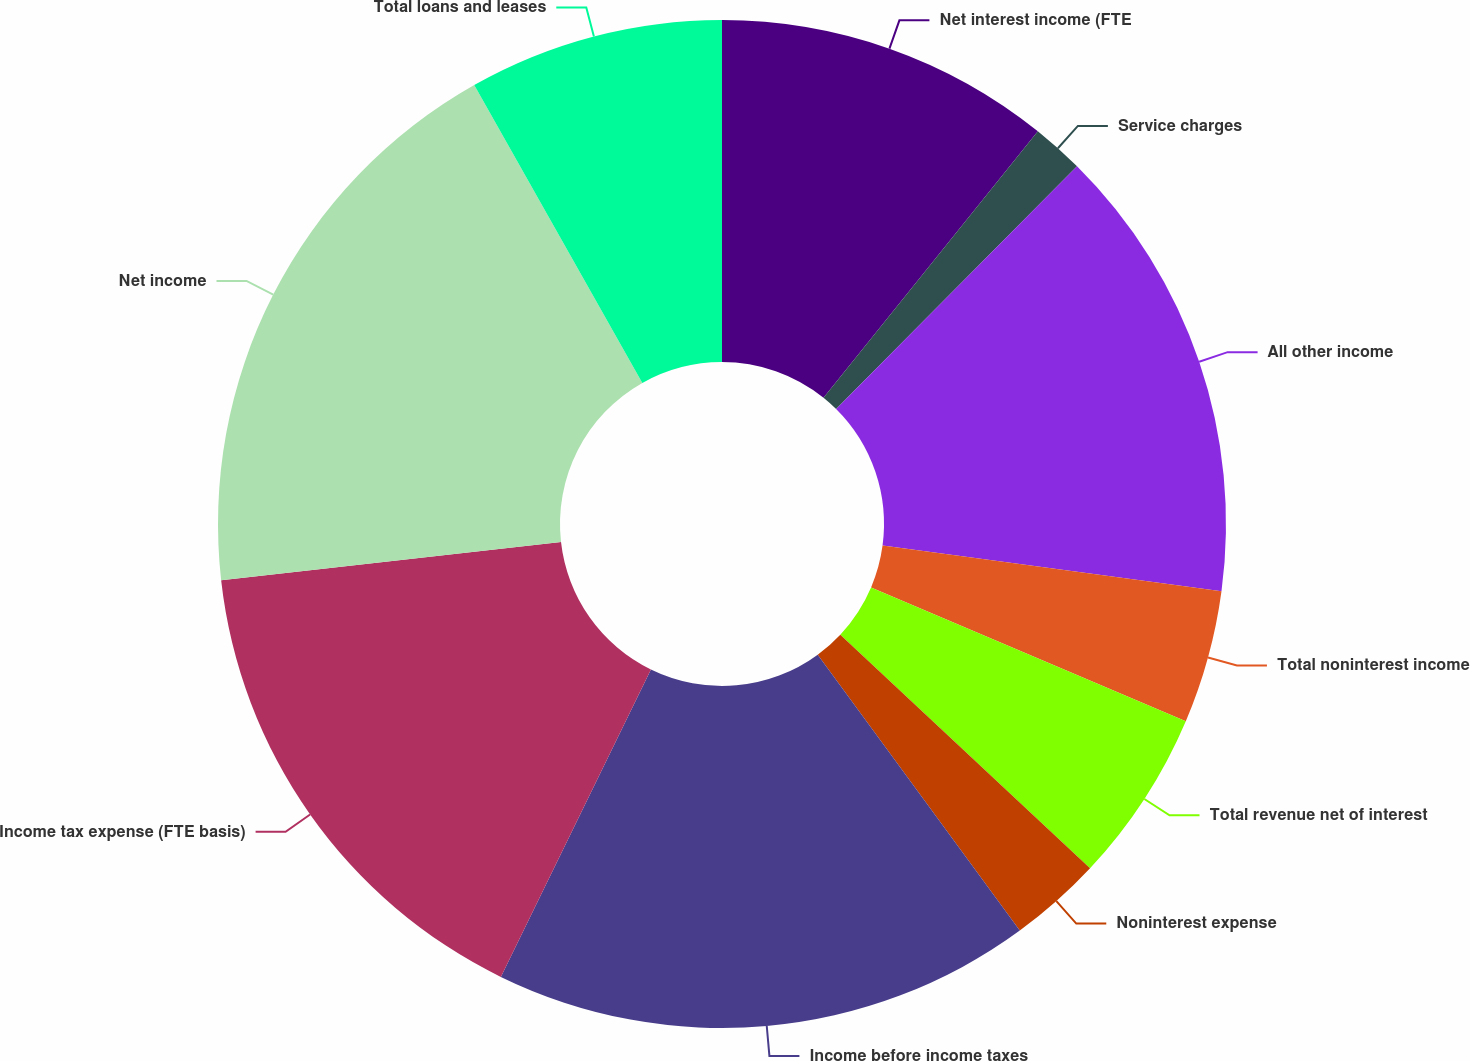Convert chart to OTSL. <chart><loc_0><loc_0><loc_500><loc_500><pie_chart><fcel>Net interest income (FTE<fcel>Service charges<fcel>All other income<fcel>Total noninterest income<fcel>Total revenue net of interest<fcel>Noninterest expense<fcel>Income before income taxes<fcel>Income tax expense (FTE basis)<fcel>Net income<fcel>Total loans and leases<nl><fcel>10.78%<fcel>1.66%<fcel>14.69%<fcel>4.27%<fcel>5.57%<fcel>2.97%<fcel>17.29%<fcel>15.99%<fcel>18.6%<fcel>8.18%<nl></chart> 